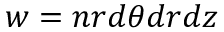<formula> <loc_0><loc_0><loc_500><loc_500>w = n r d \theta d r d z</formula> 